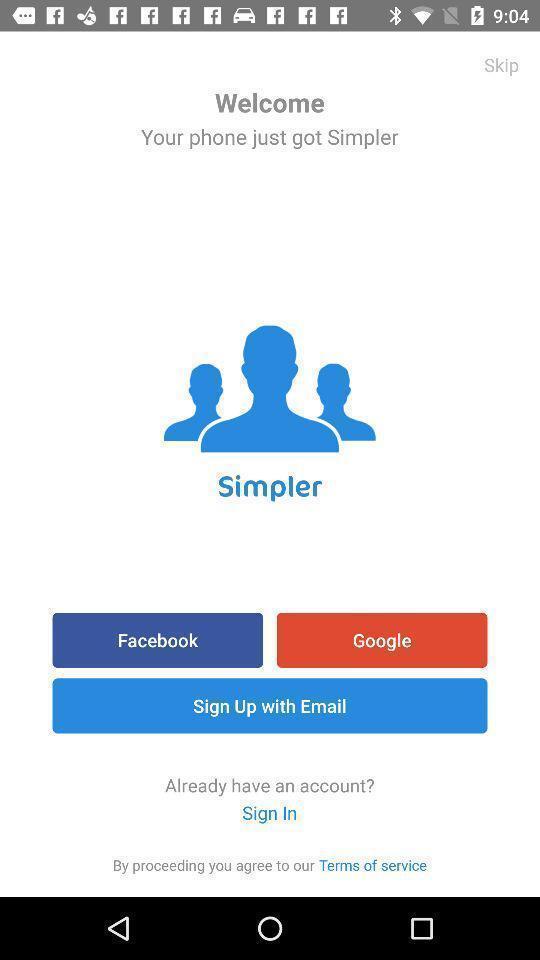Give me a narrative description of this picture. Welcome to the sign in page. 